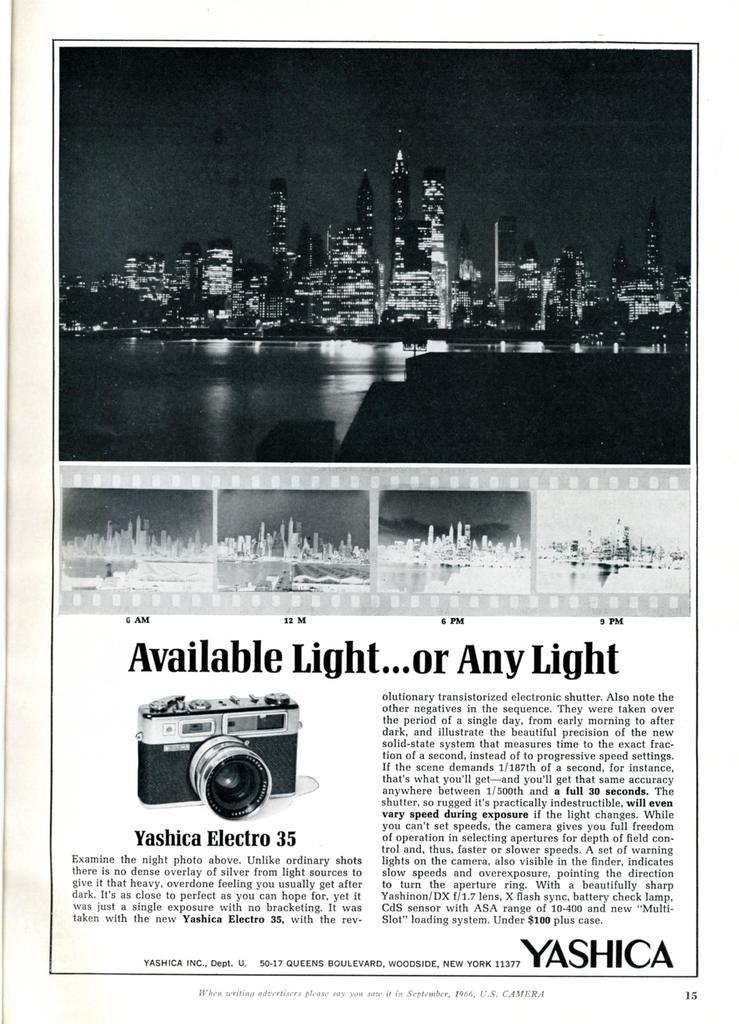<image>
Relay a brief, clear account of the picture shown. A newspaper article with the city skyline photo with the title Available Light... or any Light 